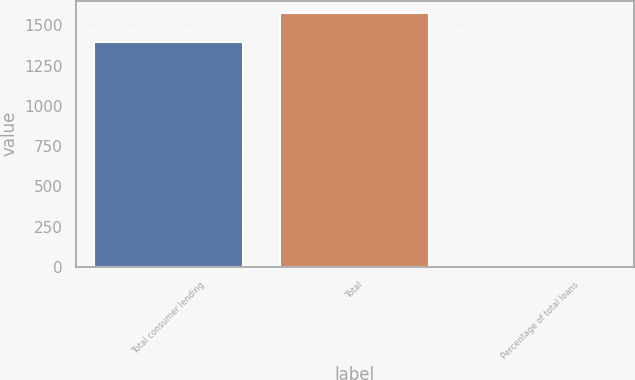<chart> <loc_0><loc_0><loc_500><loc_500><bar_chart><fcel>Total consumer lending<fcel>Total<fcel>Percentage of total loans<nl><fcel>1399<fcel>1576<fcel>0.75<nl></chart> 